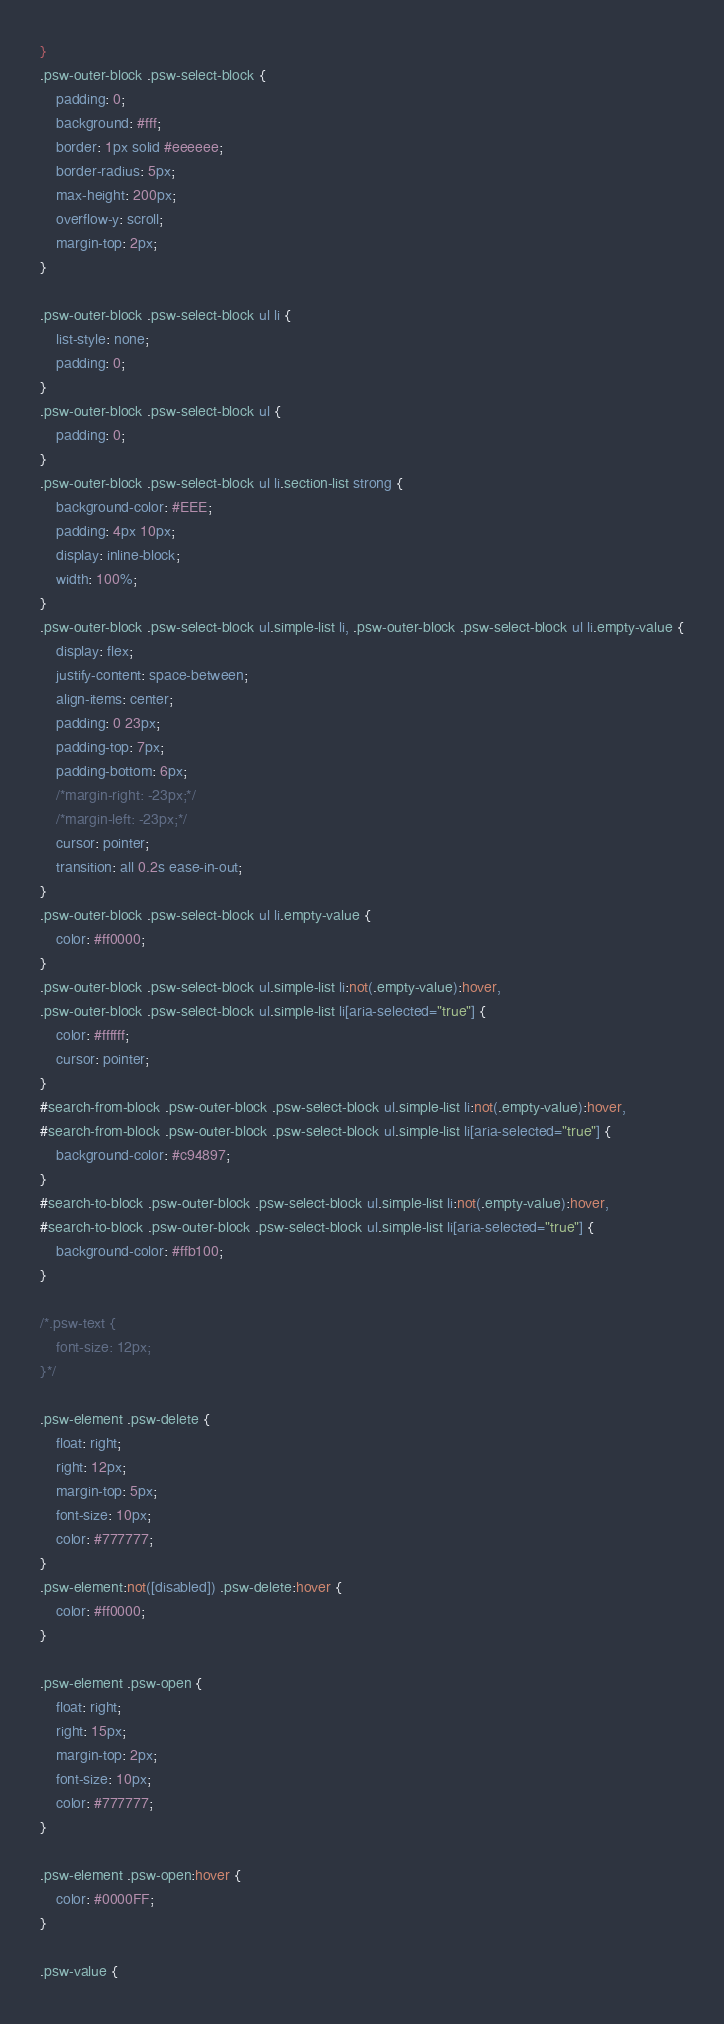<code> <loc_0><loc_0><loc_500><loc_500><_CSS_>}
.psw-outer-block .psw-select-block {
    padding: 0;
    background: #fff;
    border: 1px solid #eeeeee;
    border-radius: 5px;
    max-height: 200px;
    overflow-y: scroll;
    margin-top: 2px;
}

.psw-outer-block .psw-select-block ul li {
    list-style: none;
    padding: 0;
}
.psw-outer-block .psw-select-block ul {
    padding: 0;
}
.psw-outer-block .psw-select-block ul li.section-list strong {
    background-color: #EEE;
    padding: 4px 10px;
    display: inline-block;
    width: 100%;
}
.psw-outer-block .psw-select-block ul.simple-list li, .psw-outer-block .psw-select-block ul li.empty-value {
    display: flex;
    justify-content: space-between;
    align-items: center;
    padding: 0 23px;
    padding-top: 7px;
    padding-bottom: 6px;
    /*margin-right: -23px;*/
    /*margin-left: -23px;*/
    cursor: pointer;
    transition: all 0.2s ease-in-out;
}
.psw-outer-block .psw-select-block ul li.empty-value {
    color: #ff0000;
}
.psw-outer-block .psw-select-block ul.simple-list li:not(.empty-value):hover,
.psw-outer-block .psw-select-block ul.simple-list li[aria-selected="true"] {
    color: #ffffff;
    cursor: pointer;
}
#search-from-block .psw-outer-block .psw-select-block ul.simple-list li:not(.empty-value):hover,
#search-from-block .psw-outer-block .psw-select-block ul.simple-list li[aria-selected="true"] {
    background-color: #c94897;
}
#search-to-block .psw-outer-block .psw-select-block ul.simple-list li:not(.empty-value):hover,
#search-to-block .psw-outer-block .psw-select-block ul.simple-list li[aria-selected="true"] {
    background-color: #ffb100;
}

/*.psw-text {
    font-size: 12px;
}*/

.psw-element .psw-delete {
    float: right;
    right: 12px;
    margin-top: 5px;
    font-size: 10px;
    color: #777777;
}
.psw-element:not([disabled]) .psw-delete:hover {
    color: #ff0000;
}

.psw-element .psw-open {
    float: right;
    right: 15px;
    margin-top: 2px;
    font-size: 10px;
    color: #777777;
}

.psw-element .psw-open:hover {
    color: #0000FF;
}

.psw-value {</code> 